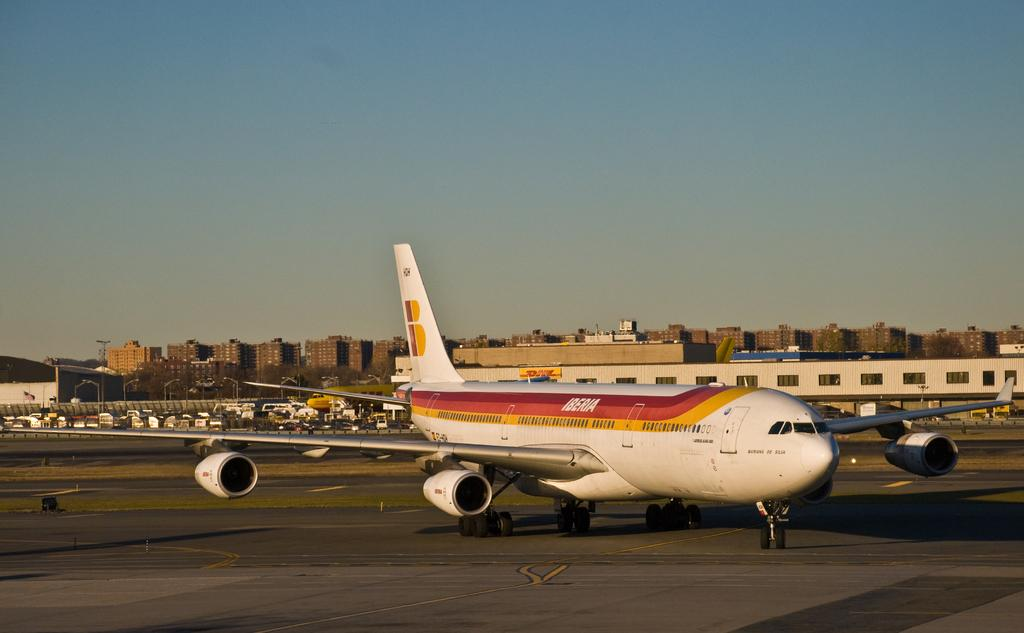What is the main subject in the foreground of the image? There is an aircraft in the foreground of the image. What other objects can be seen in the image besides the aircraft? There are vehicles and poles in the image. What can be seen in the background of the image? There are buildings and the sky visible in the background of the image. What type of sheet is being used to cover the pan in the image? There is no sheet or pan present in the image. Can you tell me how many aunts are visible in the image? There are no aunts present in the image. 